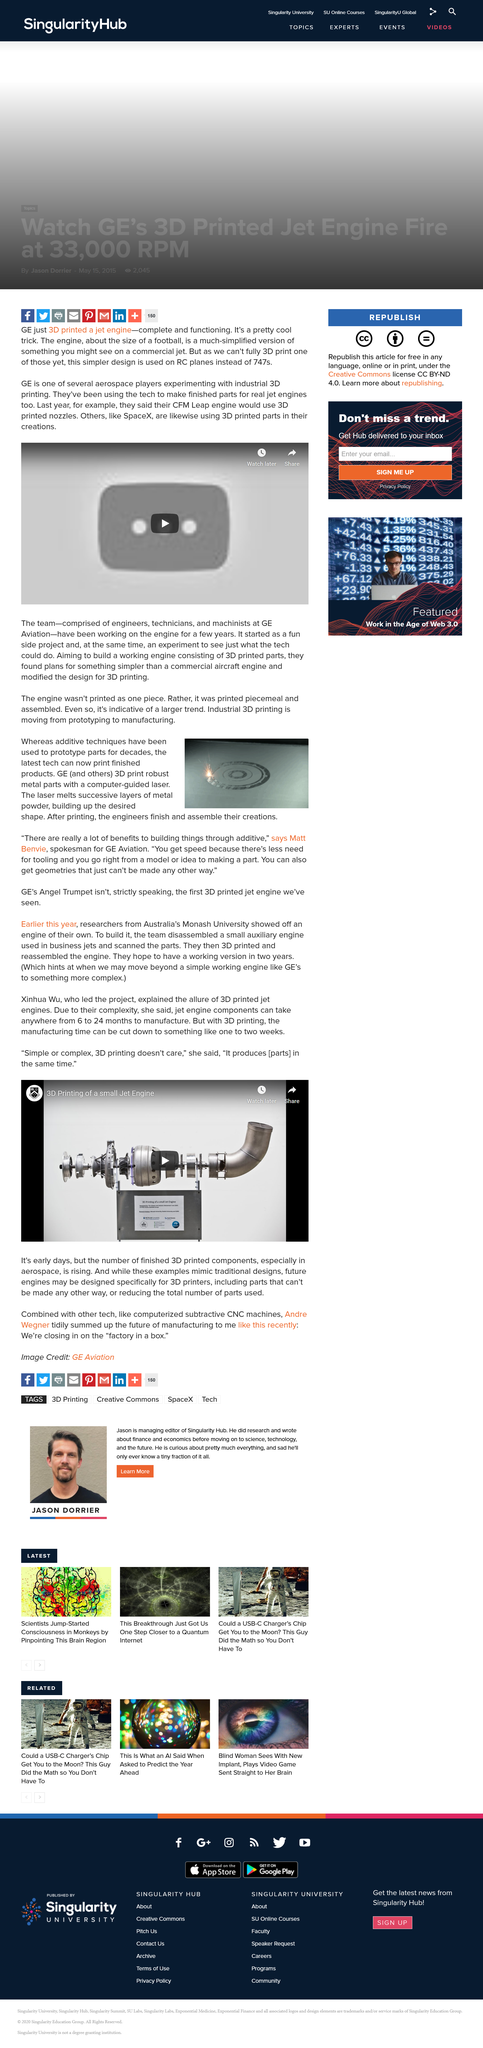Draw attention to some important aspects in this diagram. GE's Angel Trumpet is not the first 3D printed jet engine that has been seen. Matt Benvie declares that he believes in the benefits of additive techniques, stating that "there are really a lot of benefits to building things through additive. Additive techniques have long been used to prototype parts, having been employed for decades. 